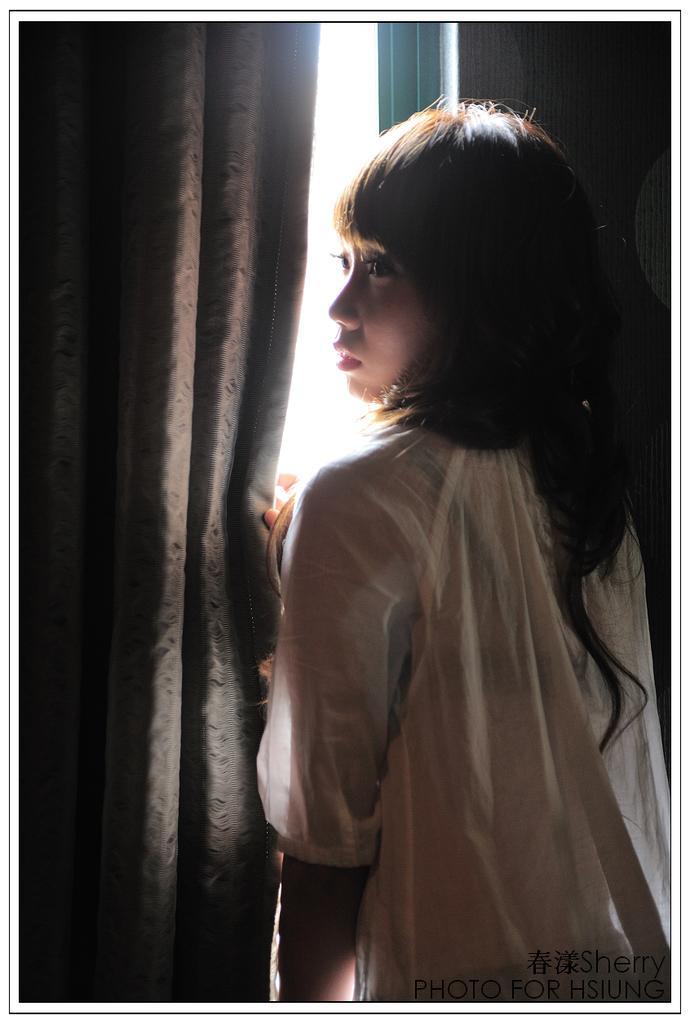Can you describe this image briefly? In this image a woman visible in front of curtain,at the bottom there is a text. 